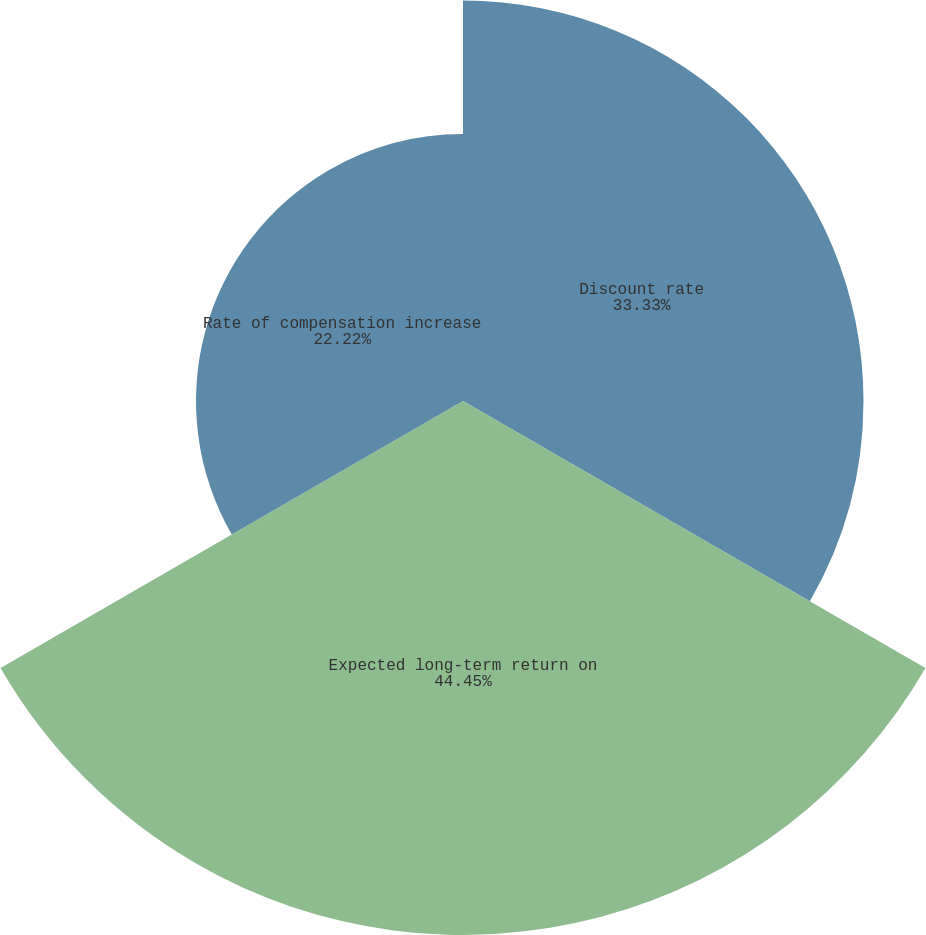Convert chart to OTSL. <chart><loc_0><loc_0><loc_500><loc_500><pie_chart><fcel>Discount rate<fcel>Expected long-term return on<fcel>Rate of compensation increase<nl><fcel>33.33%<fcel>44.44%<fcel>22.22%<nl></chart> 